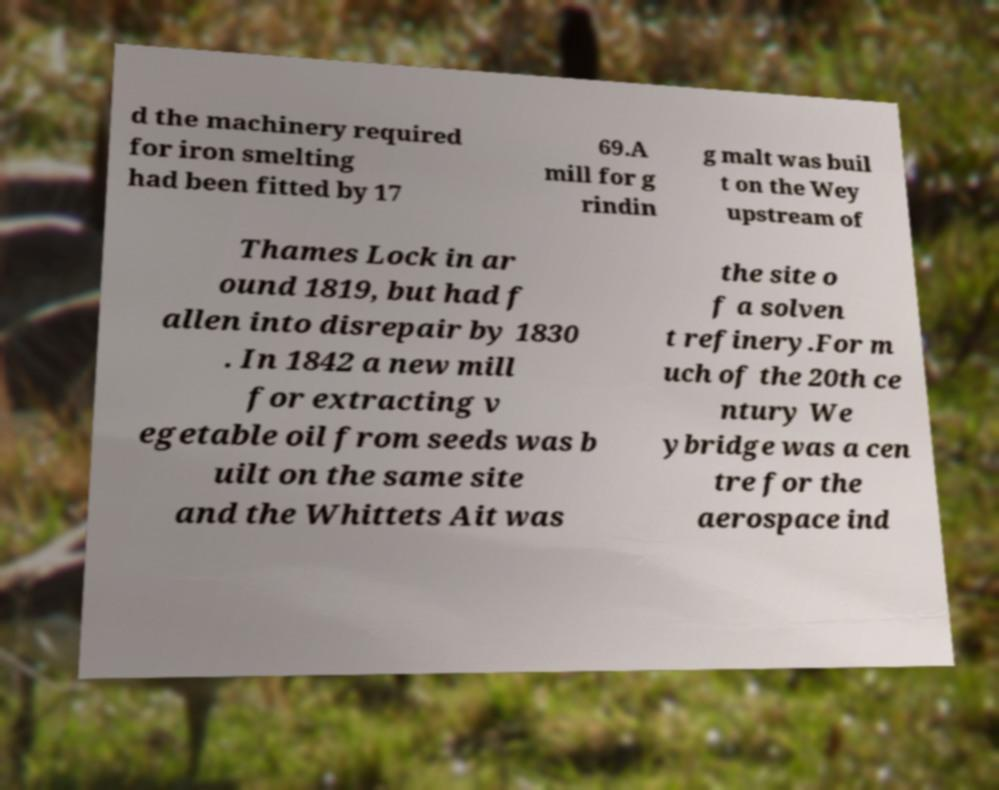Can you accurately transcribe the text from the provided image for me? d the machinery required for iron smelting had been fitted by 17 69.A mill for g rindin g malt was buil t on the Wey upstream of Thames Lock in ar ound 1819, but had f allen into disrepair by 1830 . In 1842 a new mill for extracting v egetable oil from seeds was b uilt on the same site and the Whittets Ait was the site o f a solven t refinery.For m uch of the 20th ce ntury We ybridge was a cen tre for the aerospace ind 